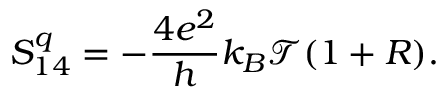<formula> <loc_0><loc_0><loc_500><loc_500>S _ { 1 4 } ^ { q } = - \frac { 4 e ^ { 2 } } { h } k _ { B } \mathcal { T } ( 1 + R ) .</formula> 